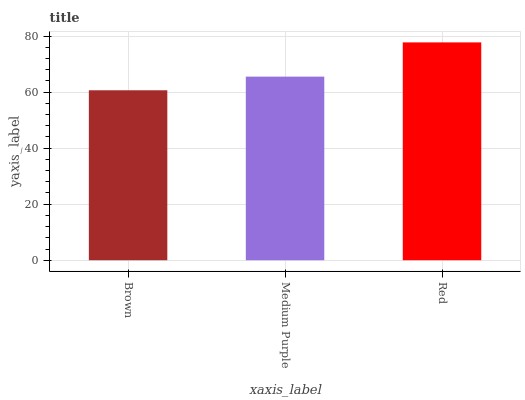Is Brown the minimum?
Answer yes or no. Yes. Is Red the maximum?
Answer yes or no. Yes. Is Medium Purple the minimum?
Answer yes or no. No. Is Medium Purple the maximum?
Answer yes or no. No. Is Medium Purple greater than Brown?
Answer yes or no. Yes. Is Brown less than Medium Purple?
Answer yes or no. Yes. Is Brown greater than Medium Purple?
Answer yes or no. No. Is Medium Purple less than Brown?
Answer yes or no. No. Is Medium Purple the high median?
Answer yes or no. Yes. Is Medium Purple the low median?
Answer yes or no. Yes. Is Red the high median?
Answer yes or no. No. Is Red the low median?
Answer yes or no. No. 